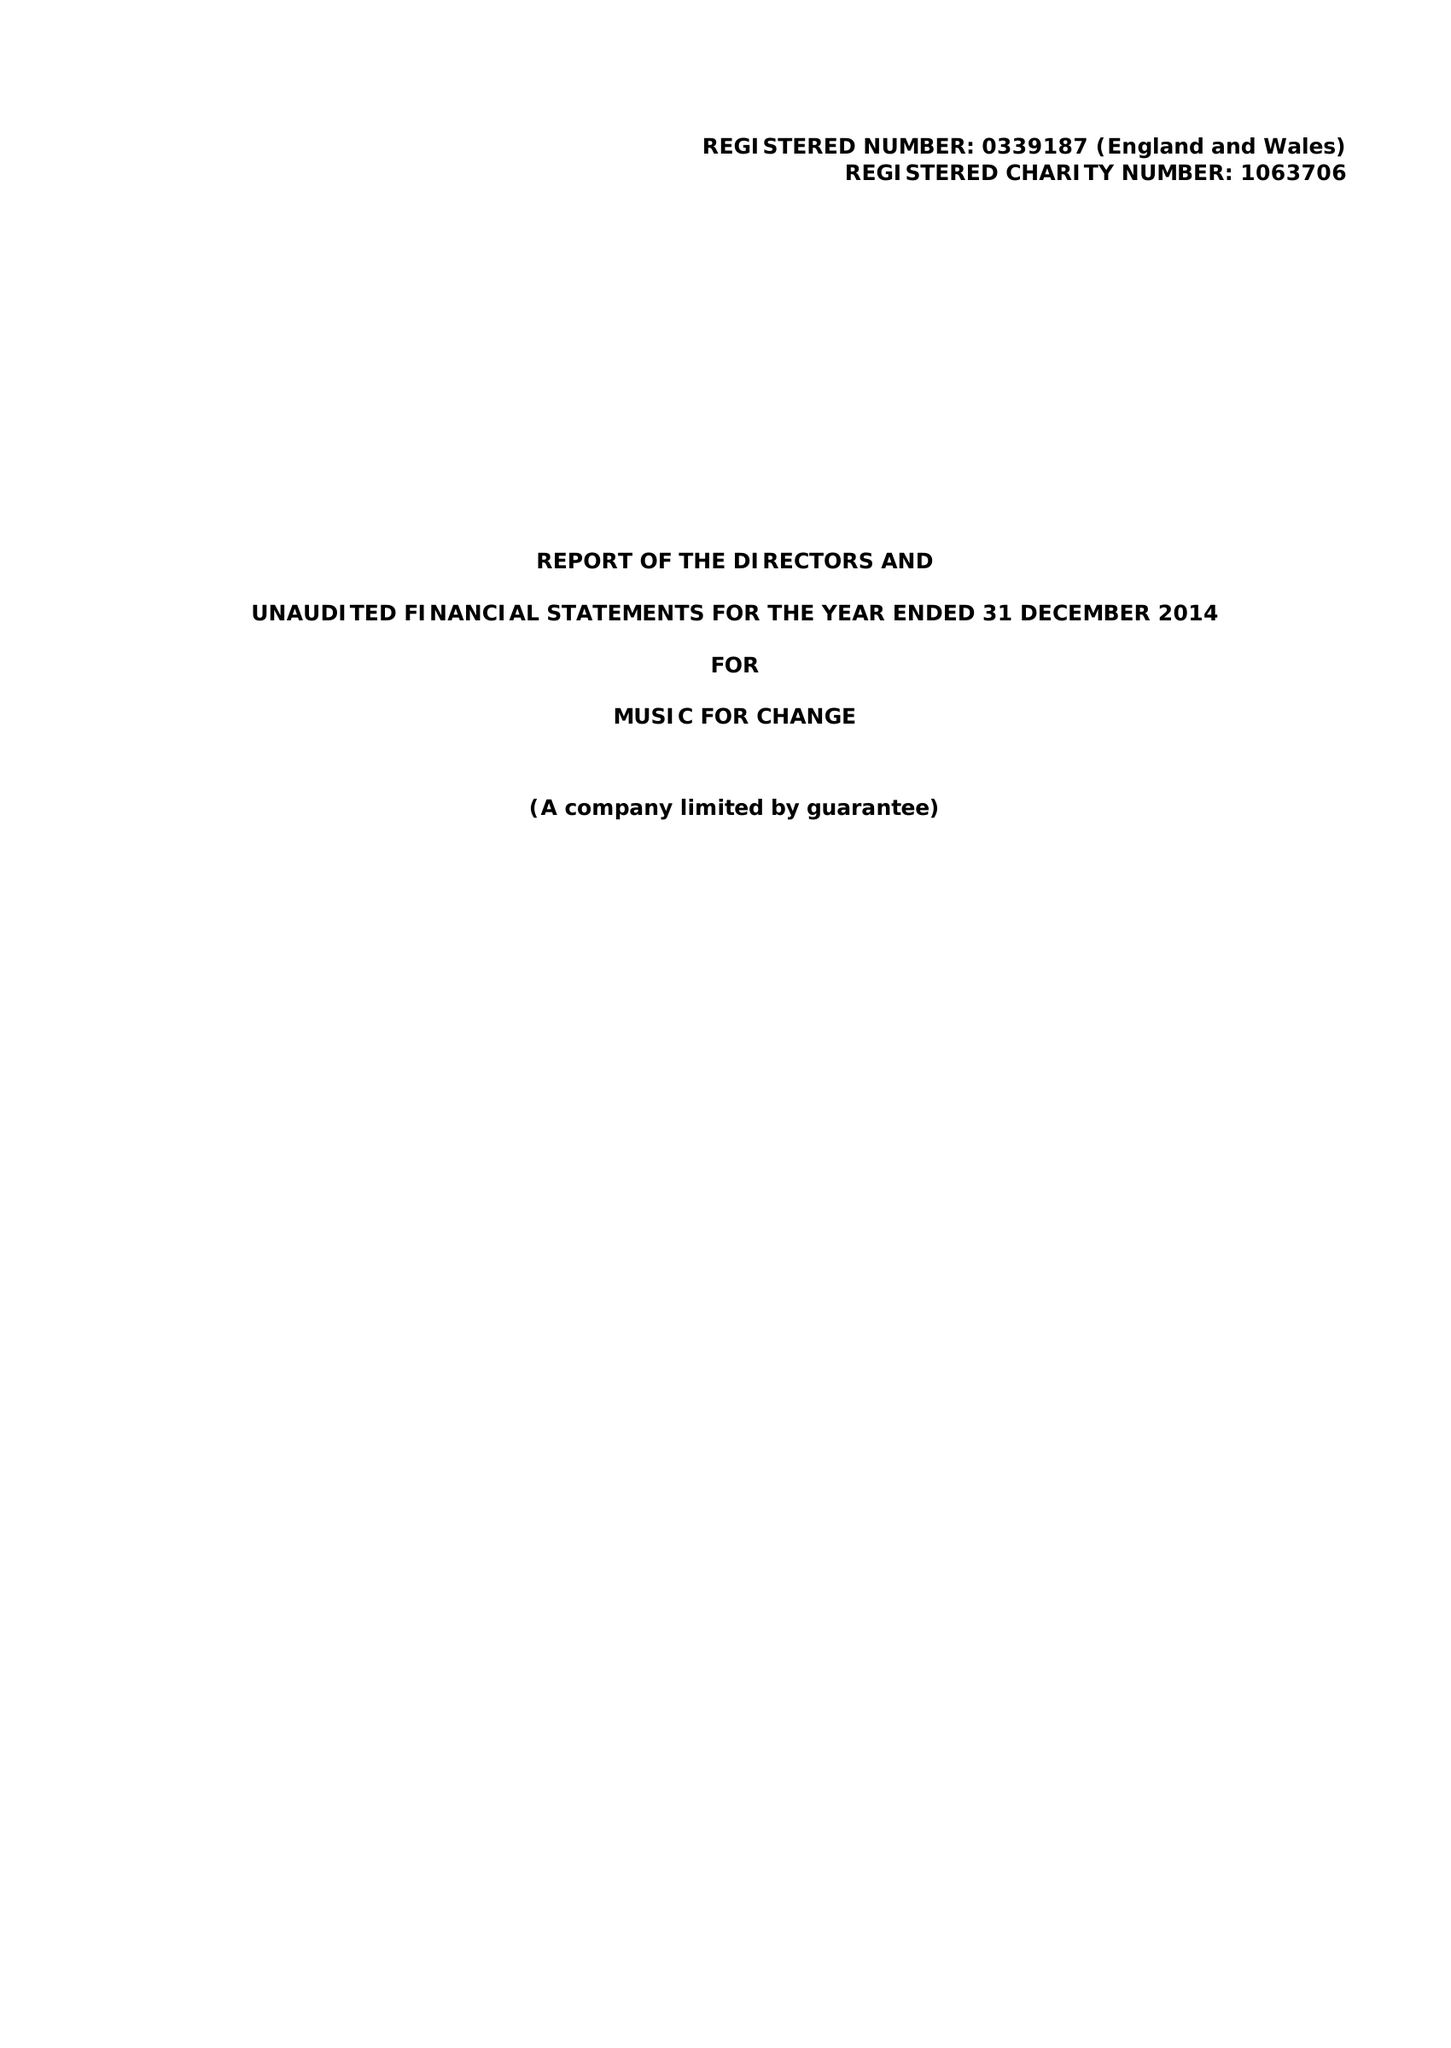What is the value for the income_annually_in_british_pounds?
Answer the question using a single word or phrase. 136314.00 